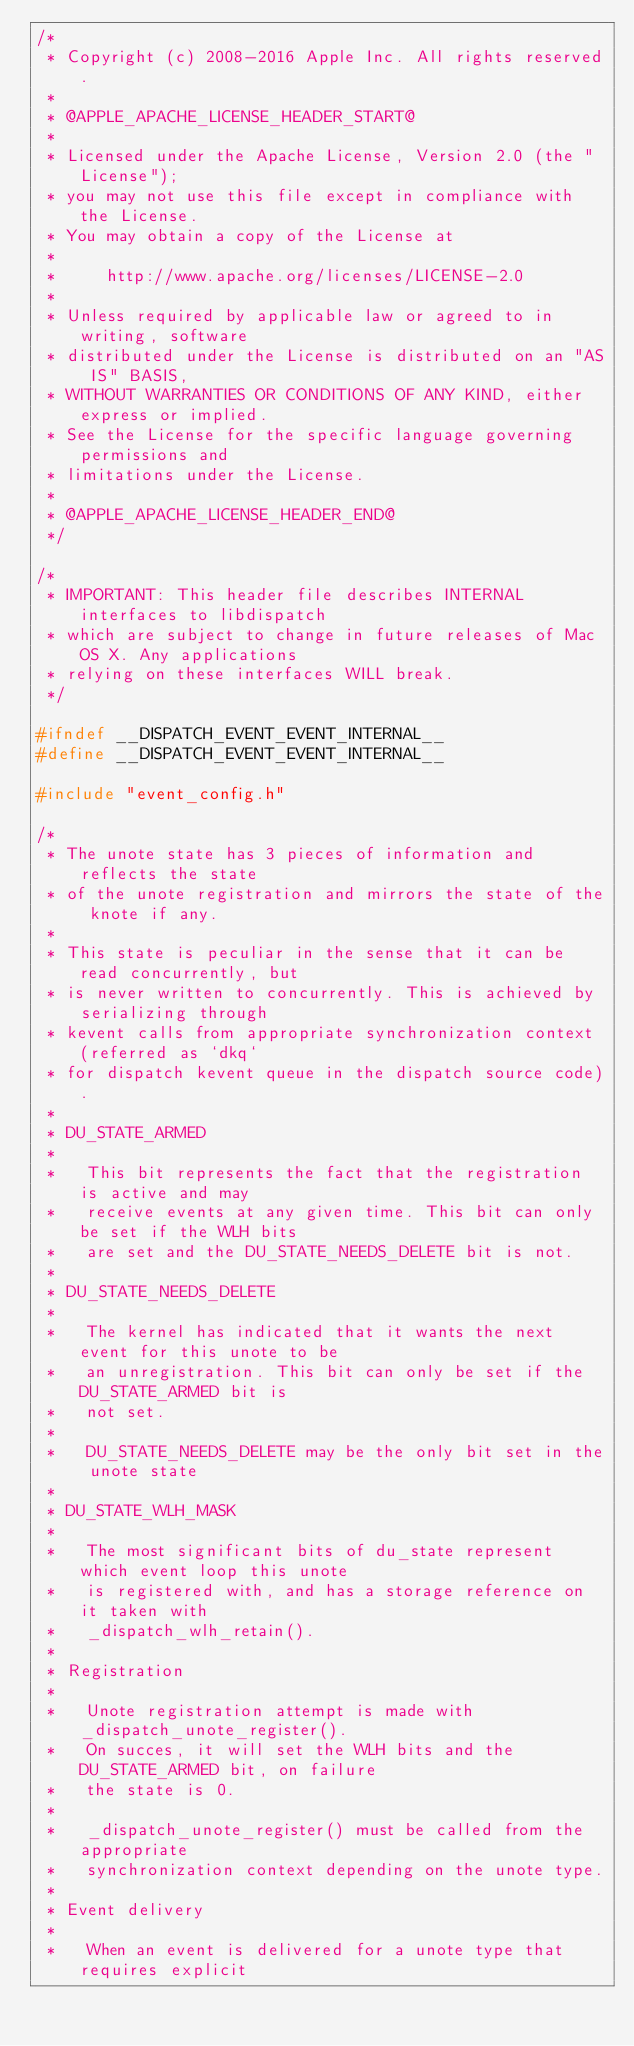<code> <loc_0><loc_0><loc_500><loc_500><_C_>/*
 * Copyright (c) 2008-2016 Apple Inc. All rights reserved.
 *
 * @APPLE_APACHE_LICENSE_HEADER_START@
 *
 * Licensed under the Apache License, Version 2.0 (the "License");
 * you may not use this file except in compliance with the License.
 * You may obtain a copy of the License at
 *
 *     http://www.apache.org/licenses/LICENSE-2.0
 *
 * Unless required by applicable law or agreed to in writing, software
 * distributed under the License is distributed on an "AS IS" BASIS,
 * WITHOUT WARRANTIES OR CONDITIONS OF ANY KIND, either express or implied.
 * See the License for the specific language governing permissions and
 * limitations under the License.
 *
 * @APPLE_APACHE_LICENSE_HEADER_END@
 */

/*
 * IMPORTANT: This header file describes INTERNAL interfaces to libdispatch
 * which are subject to change in future releases of Mac OS X. Any applications
 * relying on these interfaces WILL break.
 */

#ifndef __DISPATCH_EVENT_EVENT_INTERNAL__
#define __DISPATCH_EVENT_EVENT_INTERNAL__

#include "event_config.h"

/*
 * The unote state has 3 pieces of information and reflects the state
 * of the unote registration and mirrors the state of the knote if any.
 *
 * This state is peculiar in the sense that it can be read concurrently, but
 * is never written to concurrently. This is achieved by serializing through
 * kevent calls from appropriate synchronization context (referred as `dkq`
 * for dispatch kevent queue in the dispatch source code).
 *
 * DU_STATE_ARMED
 *
 *   This bit represents the fact that the registration is active and may
 *   receive events at any given time. This bit can only be set if the WLH bits
 *   are set and the DU_STATE_NEEDS_DELETE bit is not.
 *
 * DU_STATE_NEEDS_DELETE
 *
 *   The kernel has indicated that it wants the next event for this unote to be
 *   an unregistration. This bit can only be set if the DU_STATE_ARMED bit is
 *   not set.
 *
 *   DU_STATE_NEEDS_DELETE may be the only bit set in the unote state
 *
 * DU_STATE_WLH_MASK
 *
 *   The most significant bits of du_state represent which event loop this unote
 *   is registered with, and has a storage reference on it taken with
 *   _dispatch_wlh_retain().
 *
 * Registration
 *
 *   Unote registration attempt is made with _dispatch_unote_register().
 *   On succes, it will set the WLH bits and the DU_STATE_ARMED bit, on failure
 *   the state is 0.
 *
 *   _dispatch_unote_register() must be called from the appropriate
 *   synchronization context depending on the unote type.
 *
 * Event delivery
 *
 *   When an event is delivered for a unote type that requires explicit</code> 